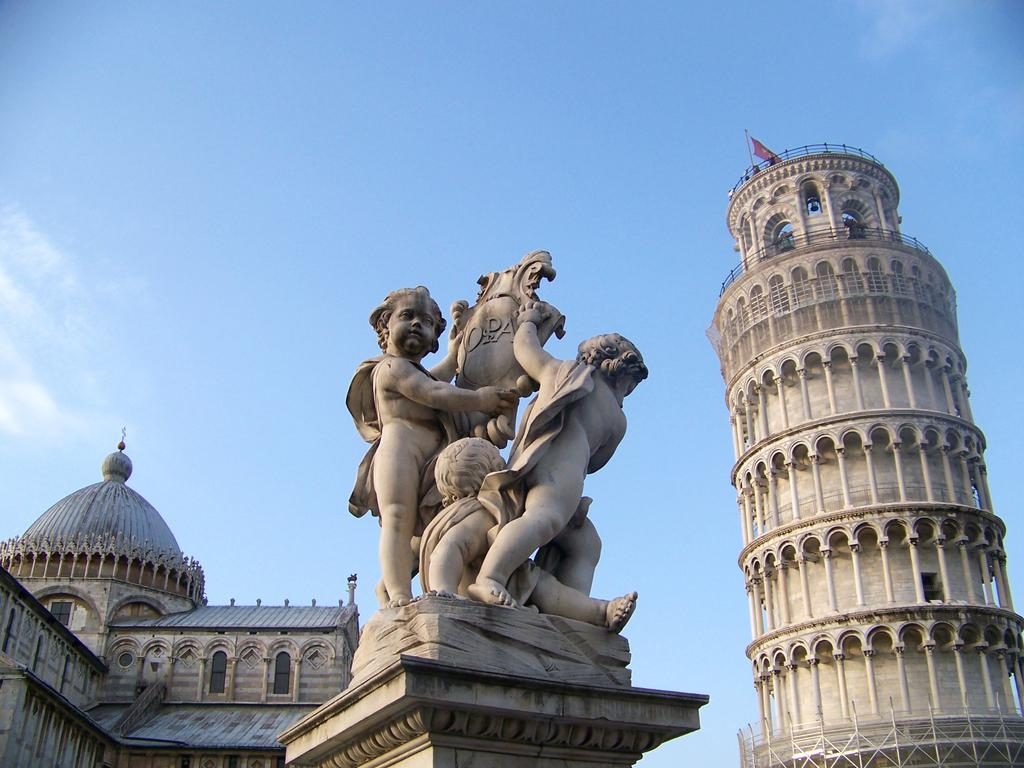What is the main subject in the image? There is a statue in the image. What other structures are present in the image? There are two buildings in the image. What can be seen on top of one of the buildings? There is a flag with a pole at the top of one of the buildings. What is visible inside the buildings? There are objects visible inside the buildings. What is visible in the background of the image? The sky is visible in the background of the image. Can you see any fish swimming in the image? There are no fish visible in the image. What type of school is depicted in the image? There is no school present in the image. 